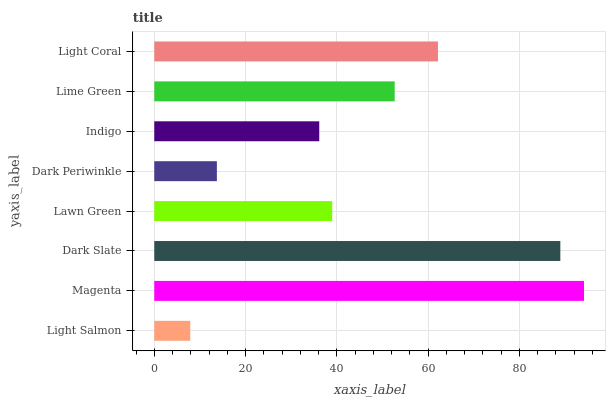Is Light Salmon the minimum?
Answer yes or no. Yes. Is Magenta the maximum?
Answer yes or no. Yes. Is Dark Slate the minimum?
Answer yes or no. No. Is Dark Slate the maximum?
Answer yes or no. No. Is Magenta greater than Dark Slate?
Answer yes or no. Yes. Is Dark Slate less than Magenta?
Answer yes or no. Yes. Is Dark Slate greater than Magenta?
Answer yes or no. No. Is Magenta less than Dark Slate?
Answer yes or no. No. Is Lime Green the high median?
Answer yes or no. Yes. Is Lawn Green the low median?
Answer yes or no. Yes. Is Lawn Green the high median?
Answer yes or no. No. Is Indigo the low median?
Answer yes or no. No. 